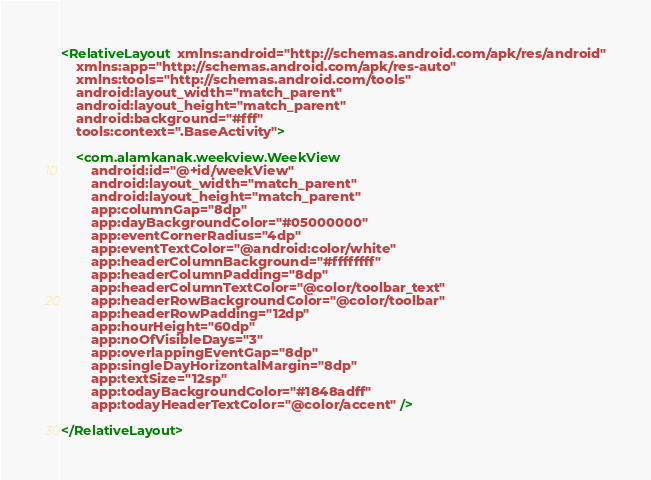Convert code to text. <code><loc_0><loc_0><loc_500><loc_500><_XML_><RelativeLayout xmlns:android="http://schemas.android.com/apk/res/android"
    xmlns:app="http://schemas.android.com/apk/res-auto"
    xmlns:tools="http://schemas.android.com/tools"
    android:layout_width="match_parent"
    android:layout_height="match_parent"
    android:background="#fff"
    tools:context=".BaseActivity">

    <com.alamkanak.weekview.WeekView
        android:id="@+id/weekView"
        android:layout_width="match_parent"
        android:layout_height="match_parent"
        app:columnGap="8dp"
        app:dayBackgroundColor="#05000000"
        app:eventCornerRadius="4dp"
        app:eventTextColor="@android:color/white"
        app:headerColumnBackground="#ffffffff"
        app:headerColumnPadding="8dp"
        app:headerColumnTextColor="@color/toolbar_text"
        app:headerRowBackgroundColor="@color/toolbar"
        app:headerRowPadding="12dp"
        app:hourHeight="60dp"
        app:noOfVisibleDays="3"
        app:overlappingEventGap="8dp"
        app:singleDayHorizontalMargin="8dp"
        app:textSize="12sp"
        app:todayBackgroundColor="#1848adff"
        app:todayHeaderTextColor="@color/accent" />

</RelativeLayout>
</code> 